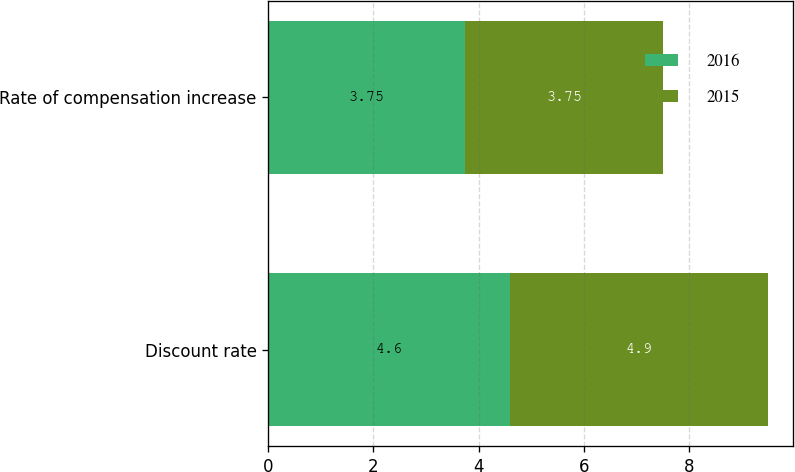Convert chart. <chart><loc_0><loc_0><loc_500><loc_500><stacked_bar_chart><ecel><fcel>Discount rate<fcel>Rate of compensation increase<nl><fcel>2016<fcel>4.6<fcel>3.75<nl><fcel>2015<fcel>4.9<fcel>3.75<nl></chart> 